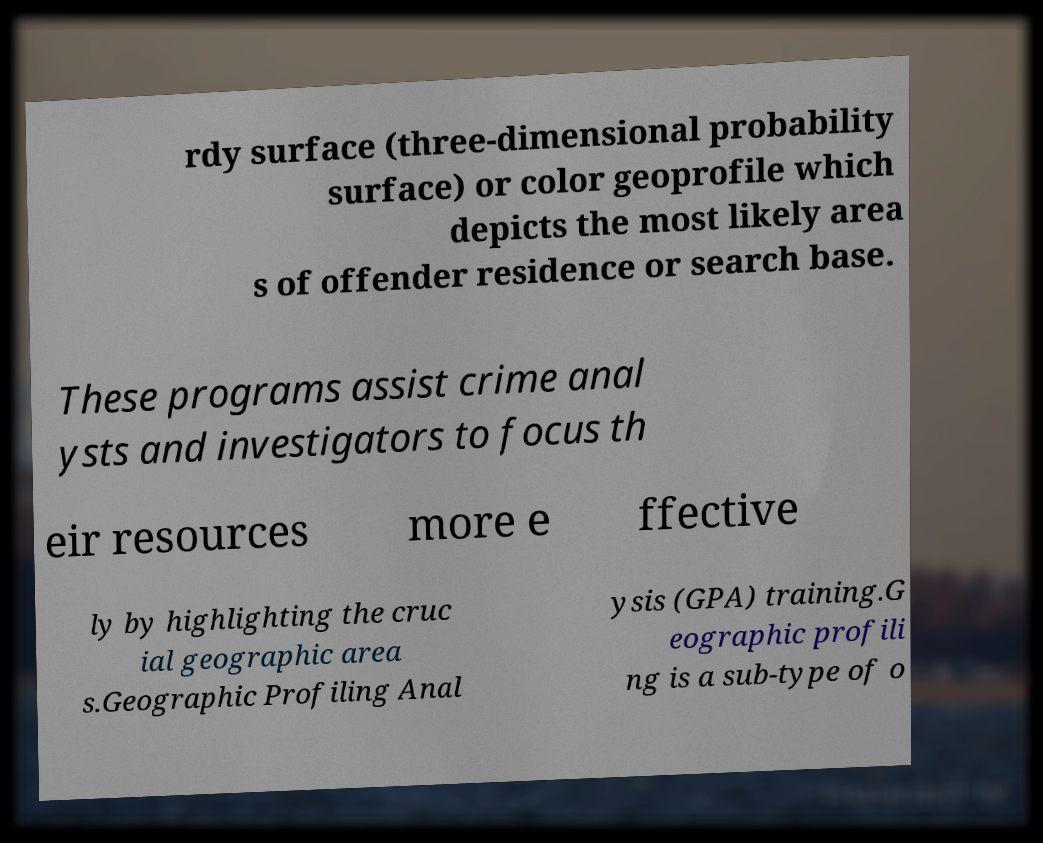Could you extract and type out the text from this image? rdy surface (three-dimensional probability surface) or color geoprofile which depicts the most likely area s of offender residence or search base. These programs assist crime anal ysts and investigators to focus th eir resources more e ffective ly by highlighting the cruc ial geographic area s.Geographic Profiling Anal ysis (GPA) training.G eographic profili ng is a sub-type of o 